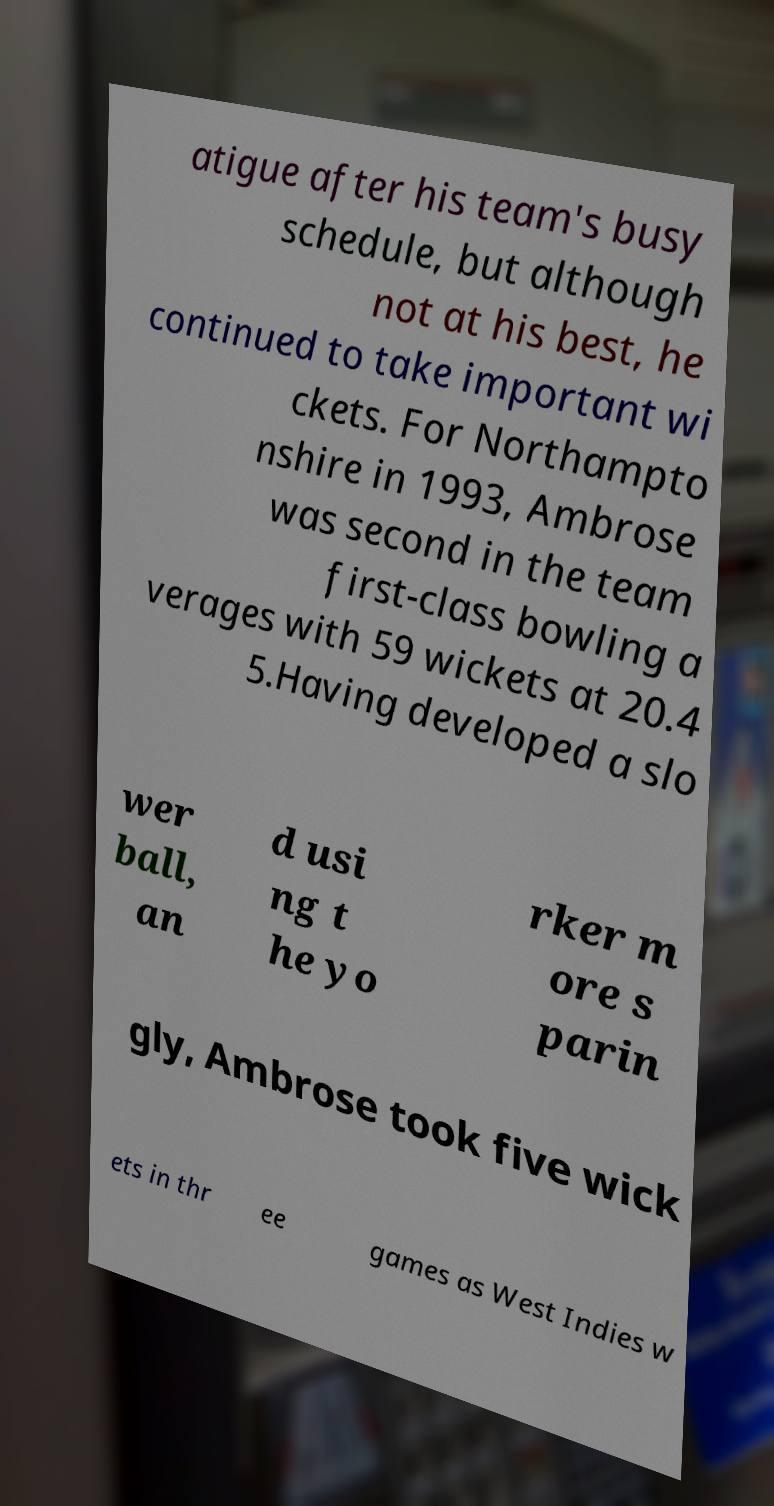Can you read and provide the text displayed in the image?This photo seems to have some interesting text. Can you extract and type it out for me? atigue after his team's busy schedule, but although not at his best, he continued to take important wi ckets. For Northampto nshire in 1993, Ambrose was second in the team first-class bowling a verages with 59 wickets at 20.4 5.Having developed a slo wer ball, an d usi ng t he yo rker m ore s parin gly, Ambrose took five wick ets in thr ee games as West Indies w 